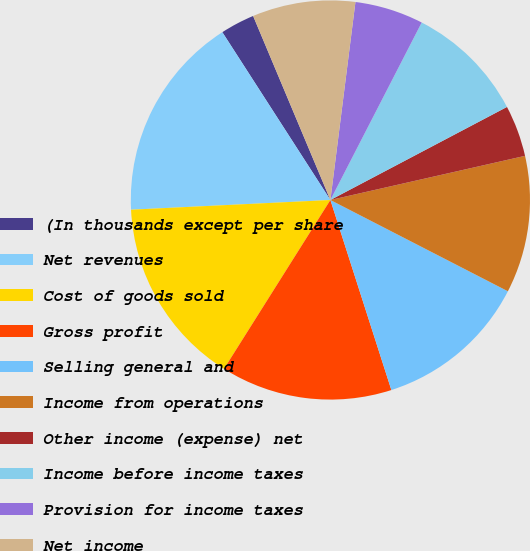Convert chart. <chart><loc_0><loc_0><loc_500><loc_500><pie_chart><fcel>(In thousands except per share<fcel>Net revenues<fcel>Cost of goods sold<fcel>Gross profit<fcel>Selling general and<fcel>Income from operations<fcel>Other income (expense) net<fcel>Income before income taxes<fcel>Provision for income taxes<fcel>Net income<nl><fcel>2.78%<fcel>16.67%<fcel>15.28%<fcel>13.89%<fcel>12.5%<fcel>11.11%<fcel>4.17%<fcel>9.72%<fcel>5.56%<fcel>8.33%<nl></chart> 